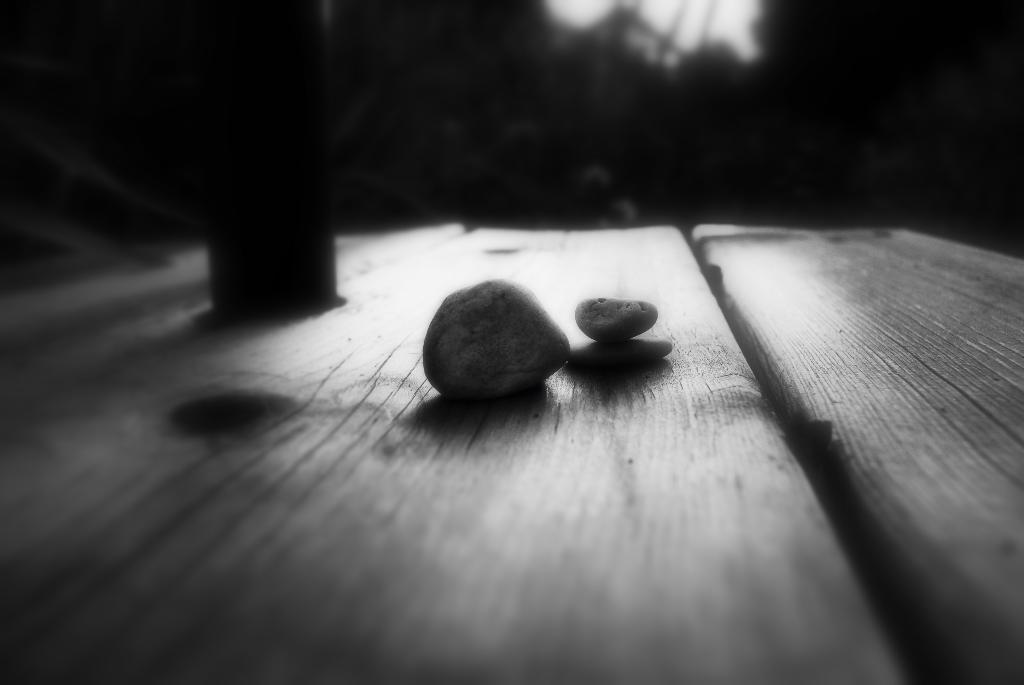Can you describe this image briefly? This picture seems to be clicked inside. In the foreground we can see the two objects seems to be the rocks placed on the top of the table. The background of the image is very dark and there are some items in the background. 